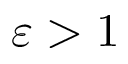<formula> <loc_0><loc_0><loc_500><loc_500>\varepsilon > 1</formula> 